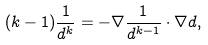Convert formula to latex. <formula><loc_0><loc_0><loc_500><loc_500>( k - 1 ) \frac { 1 } { d ^ { k } } = - \nabla \frac { 1 } { d ^ { k - 1 } } \cdot \nabla d ,</formula> 